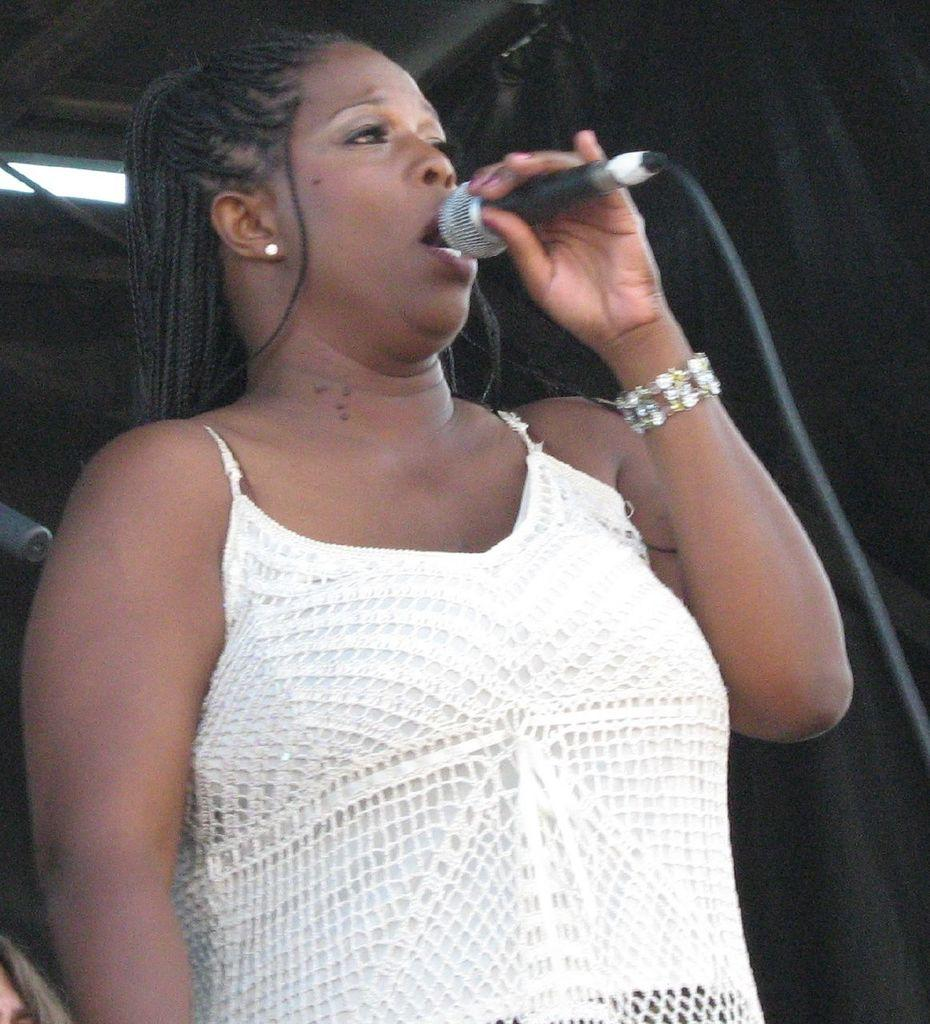Who is the main subject in the image? There is a woman in the image. What is the woman doing in the image? The woman is standing and singing a song. What is the woman holding in the image? The woman is holding a microphone. What is the woman wearing in the image? The woman is wearing a white dress. What can be seen in the background of the image? There is a black curtain in the background of the image. What type of sponge can be seen on the woman's head in the image? There is no sponge present on the woman's head in the image. Is the woman walking or standing still in the image? The woman is standing in the image, not walking. 